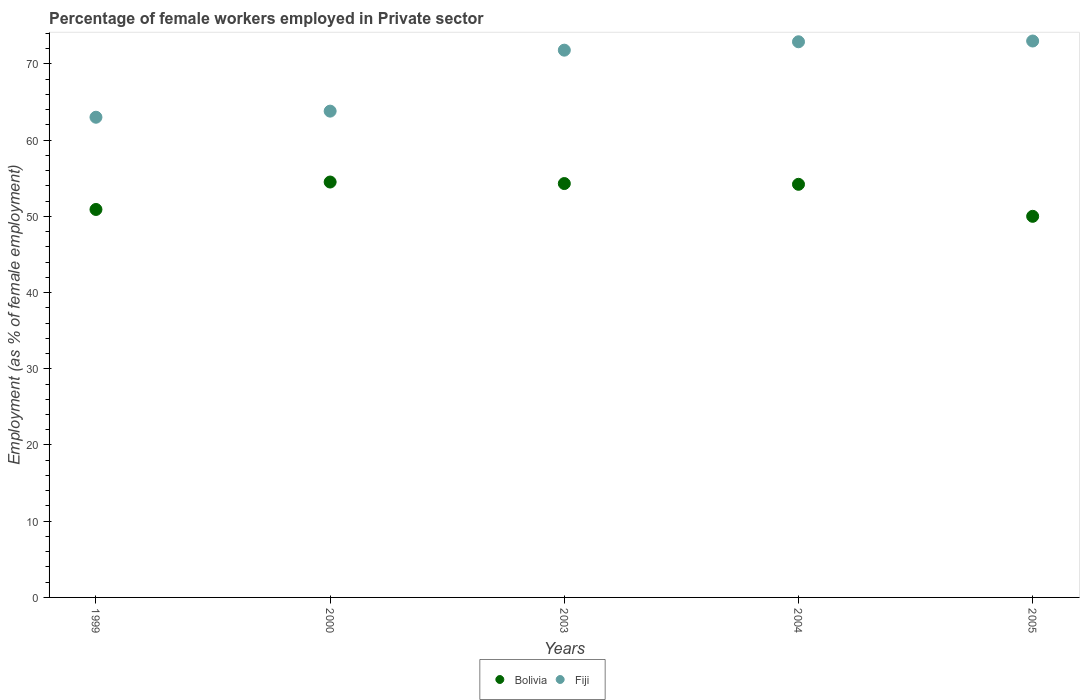Is the number of dotlines equal to the number of legend labels?
Ensure brevity in your answer.  Yes. What is the percentage of females employed in Private sector in Bolivia in 2004?
Provide a succinct answer. 54.2. Across all years, what is the maximum percentage of females employed in Private sector in Fiji?
Keep it short and to the point. 73. What is the total percentage of females employed in Private sector in Fiji in the graph?
Your answer should be compact. 344.5. What is the difference between the percentage of females employed in Private sector in Bolivia in 1999 and that in 2005?
Your answer should be compact. 0.9. What is the difference between the percentage of females employed in Private sector in Bolivia in 2003 and the percentage of females employed in Private sector in Fiji in 2005?
Ensure brevity in your answer.  -18.7. What is the average percentage of females employed in Private sector in Fiji per year?
Provide a succinct answer. 68.9. In the year 1999, what is the difference between the percentage of females employed in Private sector in Fiji and percentage of females employed in Private sector in Bolivia?
Provide a succinct answer. 12.1. What is the ratio of the percentage of females employed in Private sector in Bolivia in 2003 to that in 2004?
Make the answer very short. 1. Is the percentage of females employed in Private sector in Fiji in 2000 less than that in 2003?
Give a very brief answer. Yes. What is the difference between the highest and the second highest percentage of females employed in Private sector in Bolivia?
Make the answer very short. 0.2. What is the difference between the highest and the lowest percentage of females employed in Private sector in Fiji?
Ensure brevity in your answer.  10. In how many years, is the percentage of females employed in Private sector in Fiji greater than the average percentage of females employed in Private sector in Fiji taken over all years?
Keep it short and to the point. 3. How many dotlines are there?
Ensure brevity in your answer.  2. What is the difference between two consecutive major ticks on the Y-axis?
Make the answer very short. 10. Does the graph contain grids?
Make the answer very short. No. How many legend labels are there?
Make the answer very short. 2. What is the title of the graph?
Ensure brevity in your answer.  Percentage of female workers employed in Private sector. What is the label or title of the X-axis?
Keep it short and to the point. Years. What is the label or title of the Y-axis?
Make the answer very short. Employment (as % of female employment). What is the Employment (as % of female employment) of Bolivia in 1999?
Ensure brevity in your answer.  50.9. What is the Employment (as % of female employment) of Bolivia in 2000?
Make the answer very short. 54.5. What is the Employment (as % of female employment) in Fiji in 2000?
Offer a terse response. 63.8. What is the Employment (as % of female employment) of Bolivia in 2003?
Make the answer very short. 54.3. What is the Employment (as % of female employment) in Fiji in 2003?
Offer a very short reply. 71.8. What is the Employment (as % of female employment) of Bolivia in 2004?
Provide a short and direct response. 54.2. What is the Employment (as % of female employment) of Fiji in 2004?
Give a very brief answer. 72.9. Across all years, what is the maximum Employment (as % of female employment) of Bolivia?
Your answer should be compact. 54.5. Across all years, what is the maximum Employment (as % of female employment) of Fiji?
Provide a short and direct response. 73. What is the total Employment (as % of female employment) of Bolivia in the graph?
Provide a succinct answer. 263.9. What is the total Employment (as % of female employment) of Fiji in the graph?
Provide a succinct answer. 344.5. What is the difference between the Employment (as % of female employment) in Bolivia in 1999 and that in 2003?
Ensure brevity in your answer.  -3.4. What is the difference between the Employment (as % of female employment) of Fiji in 1999 and that in 2003?
Offer a terse response. -8.8. What is the difference between the Employment (as % of female employment) in Bolivia in 2000 and that in 2003?
Keep it short and to the point. 0.2. What is the difference between the Employment (as % of female employment) in Fiji in 2000 and that in 2005?
Offer a terse response. -9.2. What is the difference between the Employment (as % of female employment) of Bolivia in 2003 and that in 2004?
Provide a succinct answer. 0.1. What is the difference between the Employment (as % of female employment) in Bolivia in 1999 and the Employment (as % of female employment) in Fiji in 2003?
Make the answer very short. -20.9. What is the difference between the Employment (as % of female employment) in Bolivia in 1999 and the Employment (as % of female employment) in Fiji in 2004?
Provide a succinct answer. -22. What is the difference between the Employment (as % of female employment) in Bolivia in 1999 and the Employment (as % of female employment) in Fiji in 2005?
Your answer should be very brief. -22.1. What is the difference between the Employment (as % of female employment) in Bolivia in 2000 and the Employment (as % of female employment) in Fiji in 2003?
Offer a terse response. -17.3. What is the difference between the Employment (as % of female employment) in Bolivia in 2000 and the Employment (as % of female employment) in Fiji in 2004?
Offer a very short reply. -18.4. What is the difference between the Employment (as % of female employment) in Bolivia in 2000 and the Employment (as % of female employment) in Fiji in 2005?
Give a very brief answer. -18.5. What is the difference between the Employment (as % of female employment) in Bolivia in 2003 and the Employment (as % of female employment) in Fiji in 2004?
Provide a short and direct response. -18.6. What is the difference between the Employment (as % of female employment) of Bolivia in 2003 and the Employment (as % of female employment) of Fiji in 2005?
Provide a short and direct response. -18.7. What is the difference between the Employment (as % of female employment) in Bolivia in 2004 and the Employment (as % of female employment) in Fiji in 2005?
Your answer should be very brief. -18.8. What is the average Employment (as % of female employment) of Bolivia per year?
Give a very brief answer. 52.78. What is the average Employment (as % of female employment) of Fiji per year?
Your answer should be compact. 68.9. In the year 2000, what is the difference between the Employment (as % of female employment) of Bolivia and Employment (as % of female employment) of Fiji?
Ensure brevity in your answer.  -9.3. In the year 2003, what is the difference between the Employment (as % of female employment) of Bolivia and Employment (as % of female employment) of Fiji?
Your answer should be compact. -17.5. In the year 2004, what is the difference between the Employment (as % of female employment) in Bolivia and Employment (as % of female employment) in Fiji?
Offer a terse response. -18.7. In the year 2005, what is the difference between the Employment (as % of female employment) of Bolivia and Employment (as % of female employment) of Fiji?
Your response must be concise. -23. What is the ratio of the Employment (as % of female employment) in Bolivia in 1999 to that in 2000?
Your response must be concise. 0.93. What is the ratio of the Employment (as % of female employment) of Fiji in 1999 to that in 2000?
Offer a very short reply. 0.99. What is the ratio of the Employment (as % of female employment) of Bolivia in 1999 to that in 2003?
Make the answer very short. 0.94. What is the ratio of the Employment (as % of female employment) in Fiji in 1999 to that in 2003?
Ensure brevity in your answer.  0.88. What is the ratio of the Employment (as % of female employment) of Bolivia in 1999 to that in 2004?
Offer a very short reply. 0.94. What is the ratio of the Employment (as % of female employment) of Fiji in 1999 to that in 2004?
Offer a very short reply. 0.86. What is the ratio of the Employment (as % of female employment) in Bolivia in 1999 to that in 2005?
Keep it short and to the point. 1.02. What is the ratio of the Employment (as % of female employment) of Fiji in 1999 to that in 2005?
Offer a terse response. 0.86. What is the ratio of the Employment (as % of female employment) in Fiji in 2000 to that in 2003?
Provide a short and direct response. 0.89. What is the ratio of the Employment (as % of female employment) of Bolivia in 2000 to that in 2004?
Ensure brevity in your answer.  1.01. What is the ratio of the Employment (as % of female employment) in Fiji in 2000 to that in 2004?
Your response must be concise. 0.88. What is the ratio of the Employment (as % of female employment) of Bolivia in 2000 to that in 2005?
Your answer should be very brief. 1.09. What is the ratio of the Employment (as % of female employment) in Fiji in 2000 to that in 2005?
Give a very brief answer. 0.87. What is the ratio of the Employment (as % of female employment) of Bolivia in 2003 to that in 2004?
Ensure brevity in your answer.  1. What is the ratio of the Employment (as % of female employment) of Fiji in 2003 to that in 2004?
Give a very brief answer. 0.98. What is the ratio of the Employment (as % of female employment) of Bolivia in 2003 to that in 2005?
Offer a terse response. 1.09. What is the ratio of the Employment (as % of female employment) of Fiji in 2003 to that in 2005?
Provide a succinct answer. 0.98. What is the ratio of the Employment (as % of female employment) in Bolivia in 2004 to that in 2005?
Keep it short and to the point. 1.08. What is the difference between the highest and the second highest Employment (as % of female employment) in Bolivia?
Make the answer very short. 0.2. What is the difference between the highest and the lowest Employment (as % of female employment) of Fiji?
Make the answer very short. 10. 